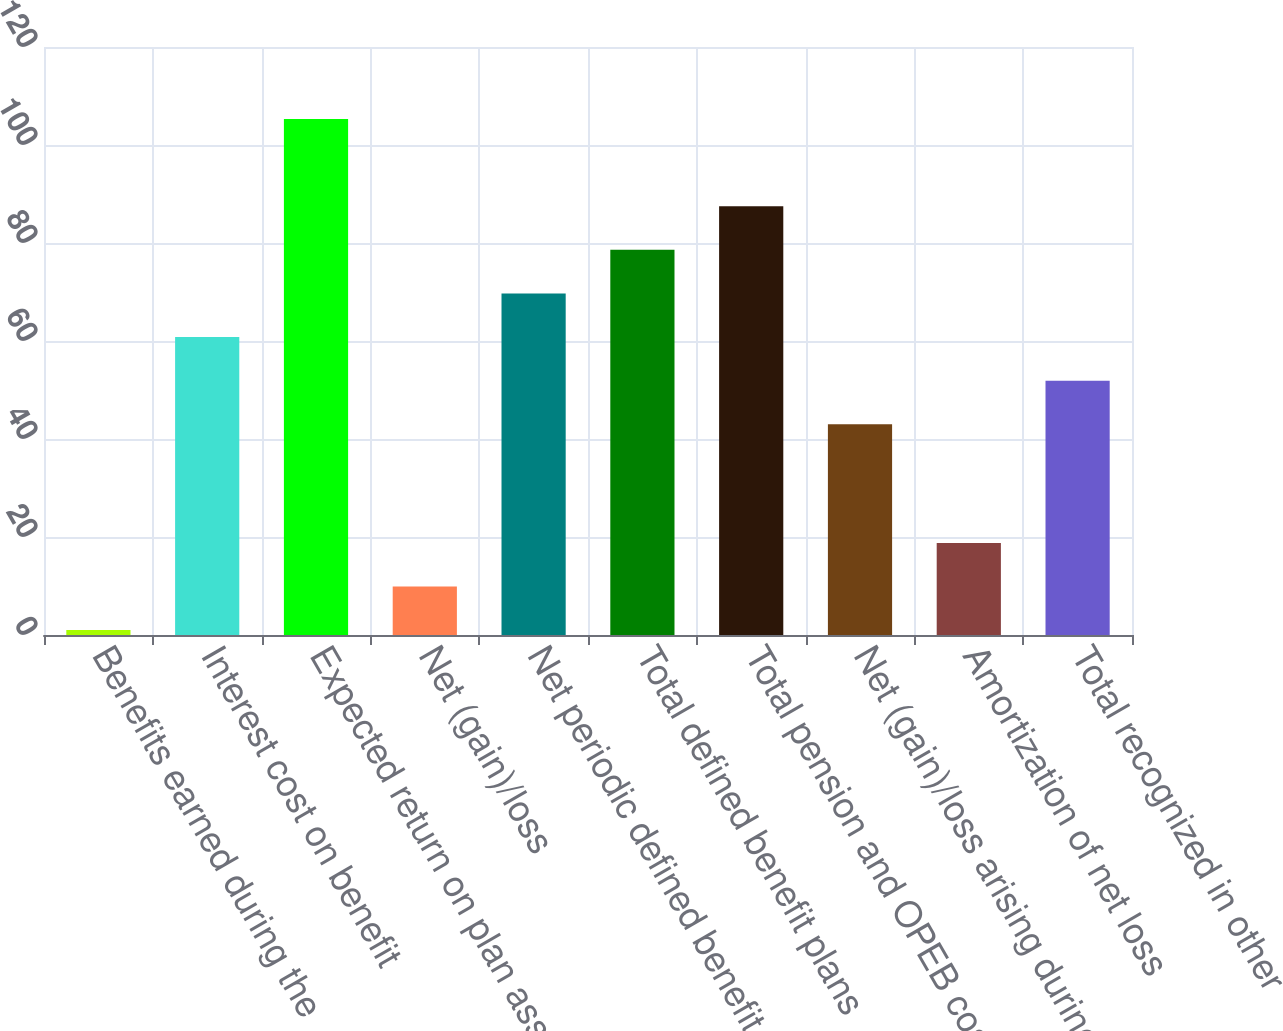Convert chart to OTSL. <chart><loc_0><loc_0><loc_500><loc_500><bar_chart><fcel>Benefits earned during the<fcel>Interest cost on benefit<fcel>Expected return on plan assets<fcel>Net (gain)/loss<fcel>Net periodic defined benefit<fcel>Total defined benefit plans<fcel>Total pension and OPEB cost<fcel>Net (gain)/loss arising during<fcel>Amortization of net loss<fcel>Total recognized in other<nl><fcel>1<fcel>60.8<fcel>105.3<fcel>9.9<fcel>69.7<fcel>78.6<fcel>87.5<fcel>43<fcel>18.8<fcel>51.9<nl></chart> 